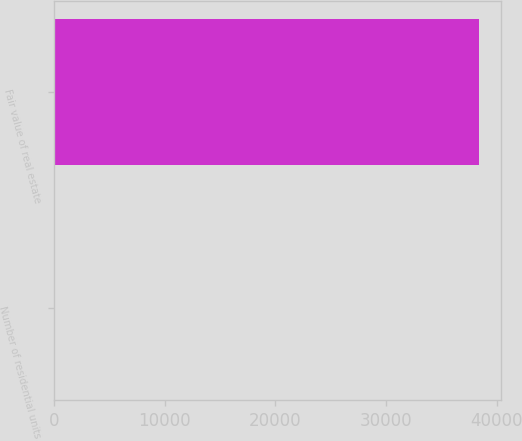Convert chart. <chart><loc_0><loc_0><loc_500><loc_500><bar_chart><fcel>Number of residential units<fcel>Fair value of real estate<nl><fcel>42<fcel>38423<nl></chart> 